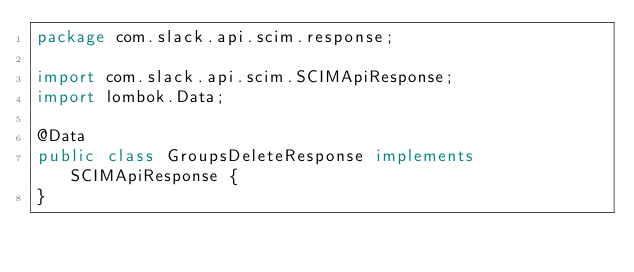Convert code to text. <code><loc_0><loc_0><loc_500><loc_500><_Java_>package com.slack.api.scim.response;

import com.slack.api.scim.SCIMApiResponse;
import lombok.Data;

@Data
public class GroupsDeleteResponse implements SCIMApiResponse {
}
</code> 